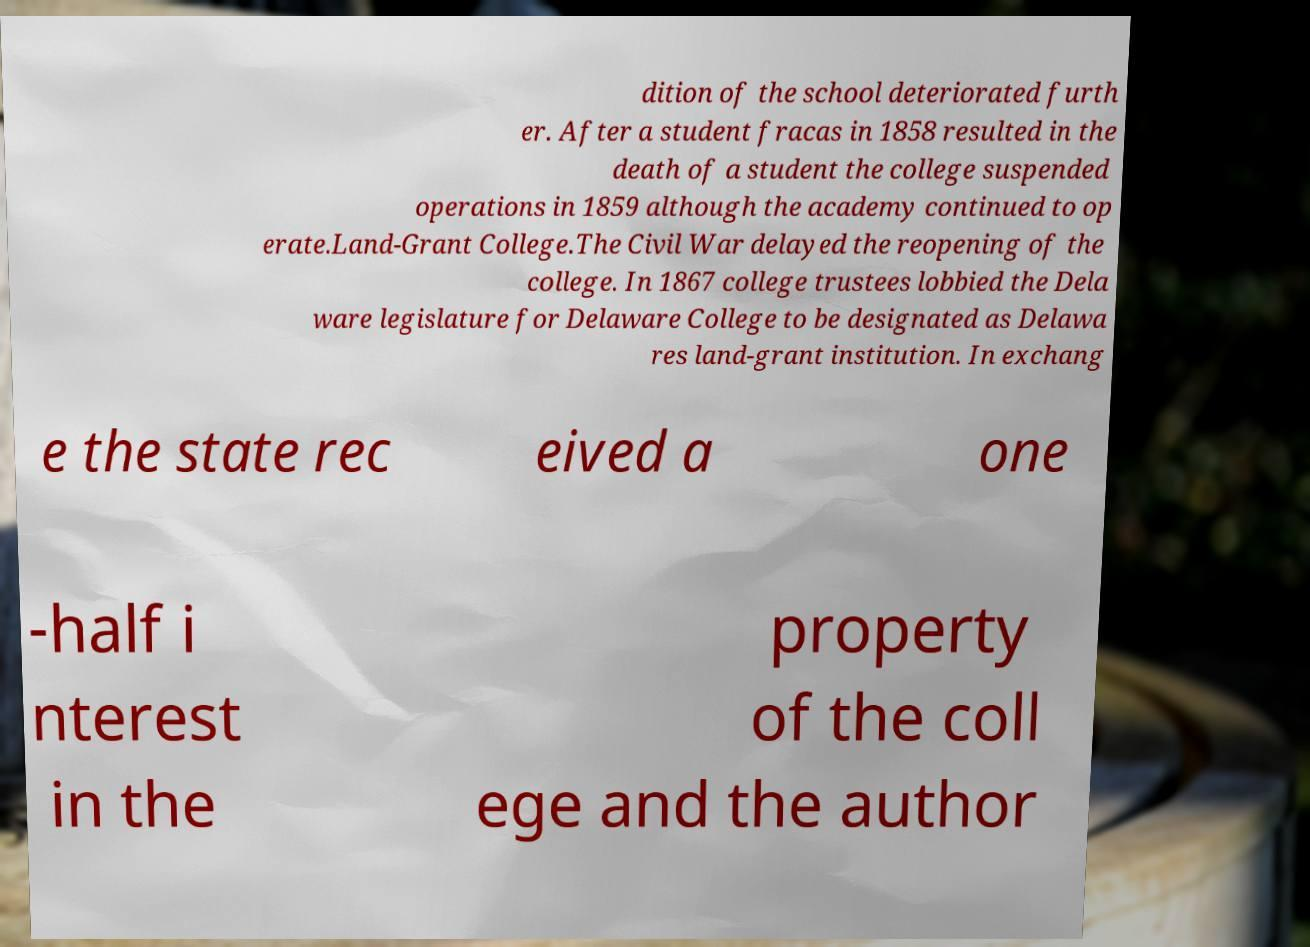I need the written content from this picture converted into text. Can you do that? dition of the school deteriorated furth er. After a student fracas in 1858 resulted in the death of a student the college suspended operations in 1859 although the academy continued to op erate.Land-Grant College.The Civil War delayed the reopening of the college. In 1867 college trustees lobbied the Dela ware legislature for Delaware College to be designated as Delawa res land-grant institution. In exchang e the state rec eived a one -half i nterest in the property of the coll ege and the author 